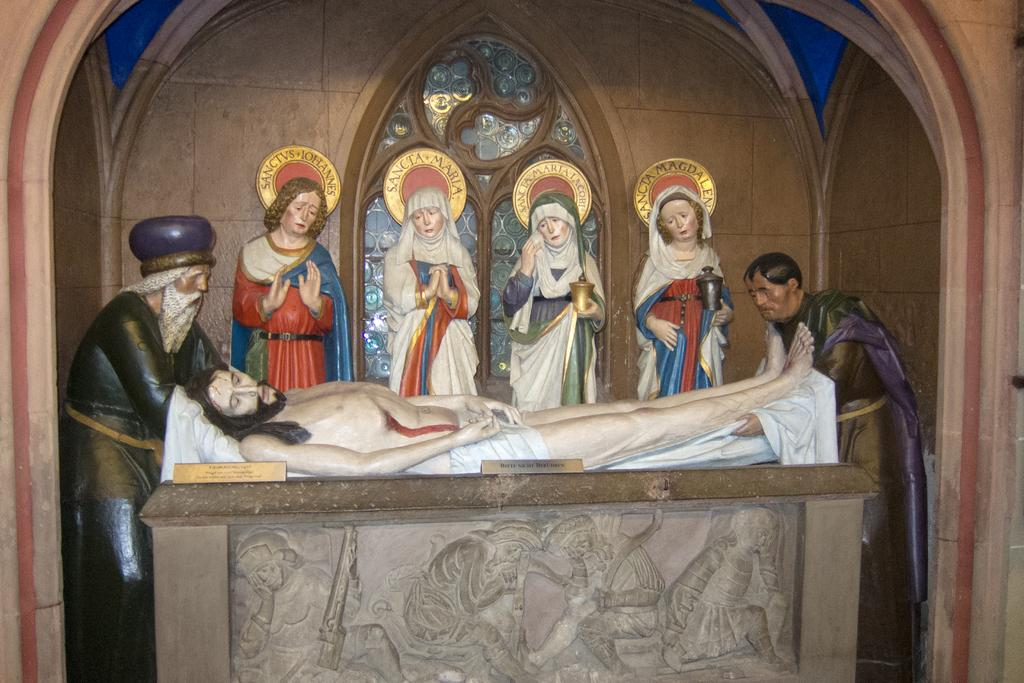How many statues are present in the image? There are three men statues and four women statues in the image, making a total of seven statues. What types of statues can be seen in the image? The statues in the image are of men and women. Are there any other elements at the bottom of the image besides the statues? Yes, there are sculptures at the bottom of the image. What can be seen in the background of the image? There is a wall visible in the background of the image. Can you tell me how many mittens are hanging on the wall in the image? There are no mittens present in the image; it features statues and sculptures. Are there any cacti visible in the image? There are no cacti present in the image. 